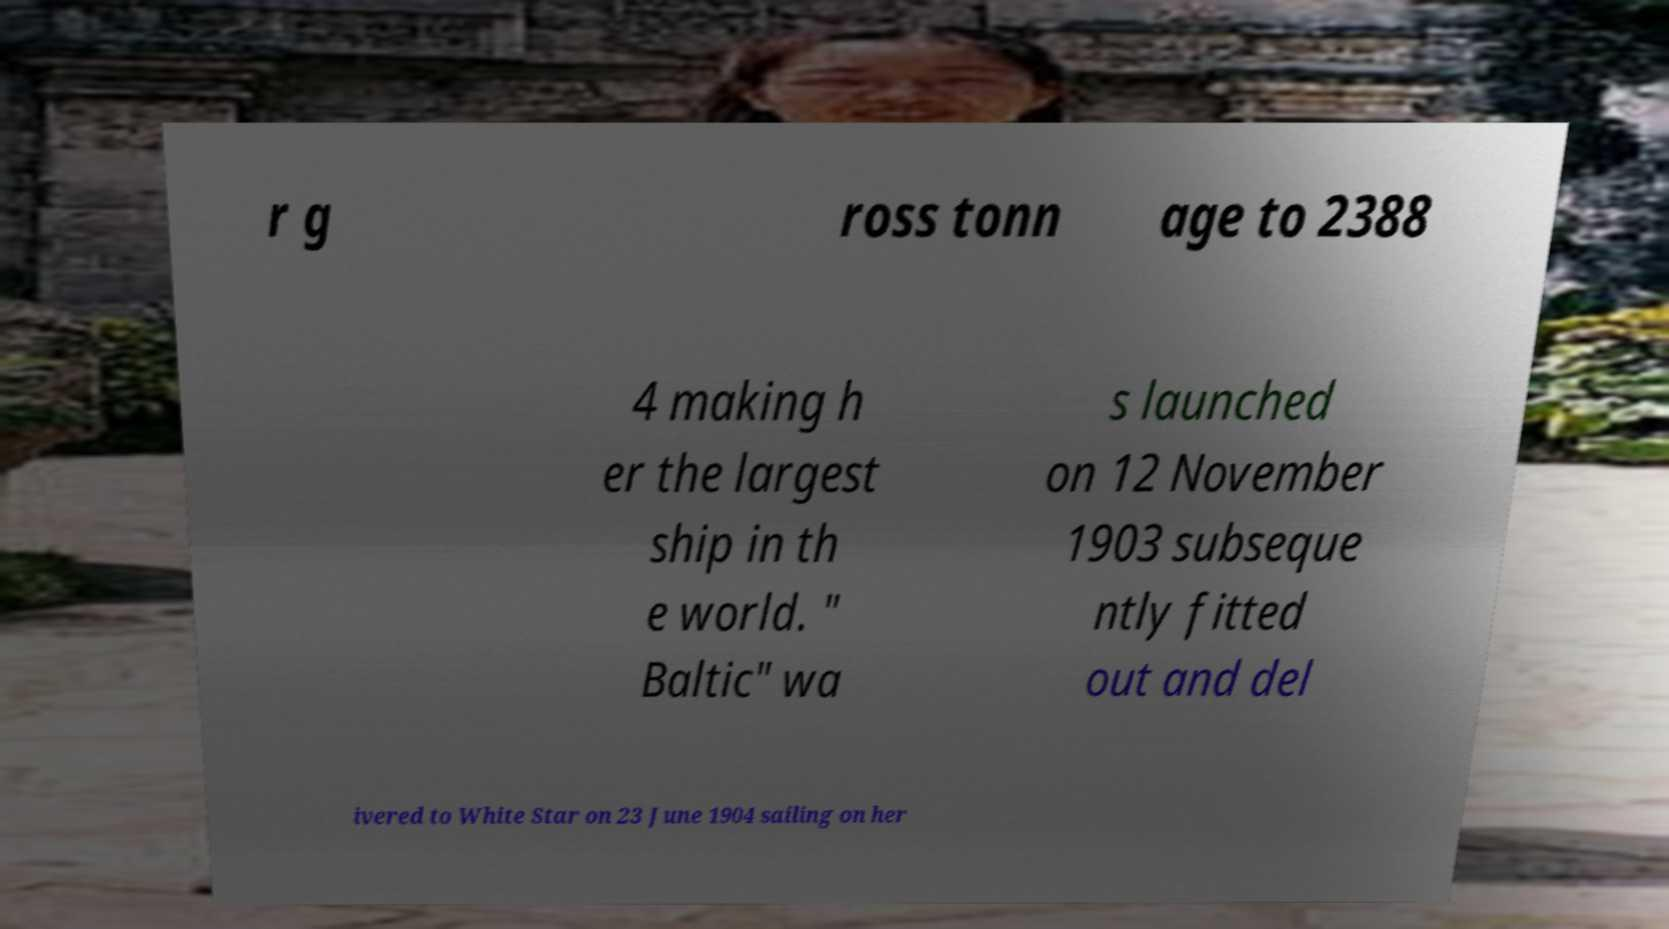Could you assist in decoding the text presented in this image and type it out clearly? r g ross tonn age to 2388 4 making h er the largest ship in th e world. " Baltic" wa s launched on 12 November 1903 subseque ntly fitted out and del ivered to White Star on 23 June 1904 sailing on her 